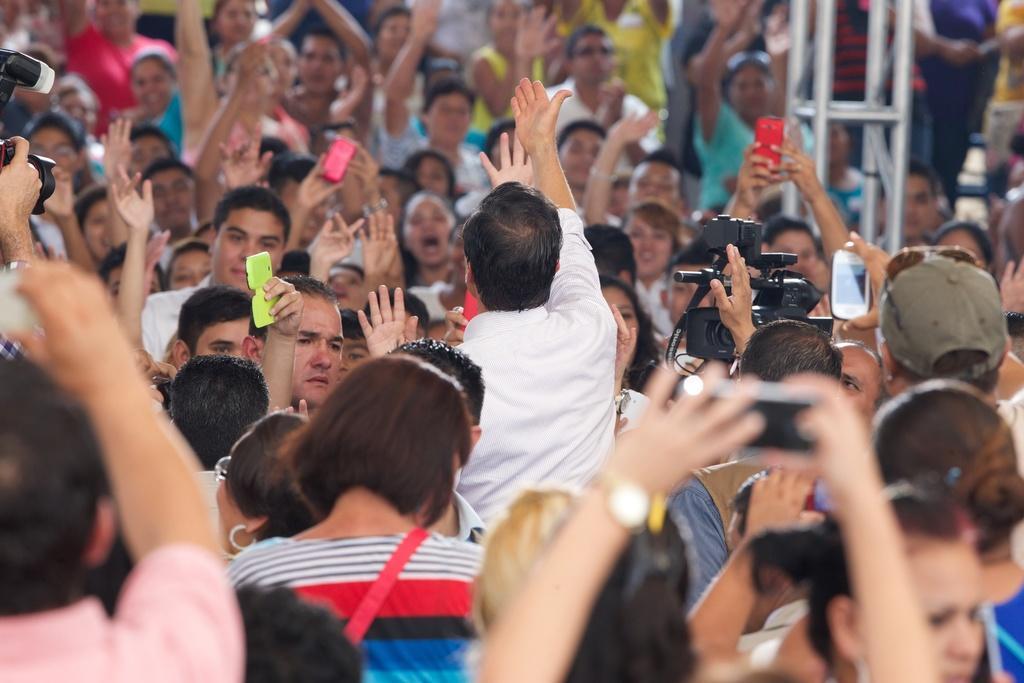Please provide a concise description of this image. In this image there are group of people raising their hands few are holding cameras in there hands. 